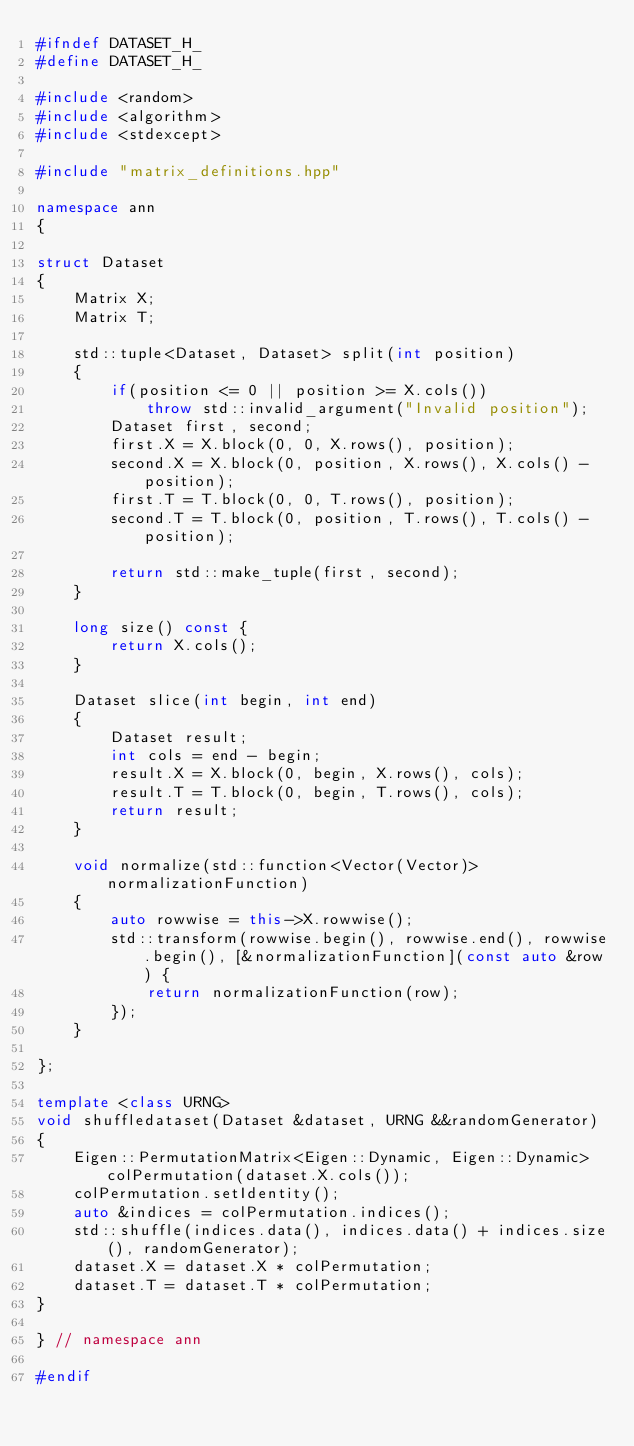<code> <loc_0><loc_0><loc_500><loc_500><_C++_>#ifndef DATASET_H_
#define DATASET_H_

#include <random>
#include <algorithm>
#include <stdexcept>

#include "matrix_definitions.hpp"

namespace ann
{

struct Dataset
{
    Matrix X;
    Matrix T;

    std::tuple<Dataset, Dataset> split(int position)
    {
        if(position <= 0 || position >= X.cols())
            throw std::invalid_argument("Invalid position");
        Dataset first, second;
        first.X = X.block(0, 0, X.rows(), position);
        second.X = X.block(0, position, X.rows(), X.cols() - position);
        first.T = T.block(0, 0, T.rows(), position);
        second.T = T.block(0, position, T.rows(), T.cols() - position);

        return std::make_tuple(first, second);
    }

    long size() const {
        return X.cols();
    }

    Dataset slice(int begin, int end)
    {
        Dataset result;
        int cols = end - begin;
        result.X = X.block(0, begin, X.rows(), cols);
        result.T = T.block(0, begin, T.rows(), cols);
        return result;
    }

    void normalize(std::function<Vector(Vector)> normalizationFunction)
    {
        auto rowwise = this->X.rowwise();
        std::transform(rowwise.begin(), rowwise.end(), rowwise.begin(), [&normalizationFunction](const auto &row) {
            return normalizationFunction(row);
        });
    }

};

template <class URNG>
void shuffledataset(Dataset &dataset, URNG &&randomGenerator)
{
    Eigen::PermutationMatrix<Eigen::Dynamic, Eigen::Dynamic> colPermutation(dataset.X.cols());
    colPermutation.setIdentity();
    auto &indices = colPermutation.indices();
    std::shuffle(indices.data(), indices.data() + indices.size(), randomGenerator);
    dataset.X = dataset.X * colPermutation;
    dataset.T = dataset.T * colPermutation;
}

} // namespace ann

#endif
</code> 